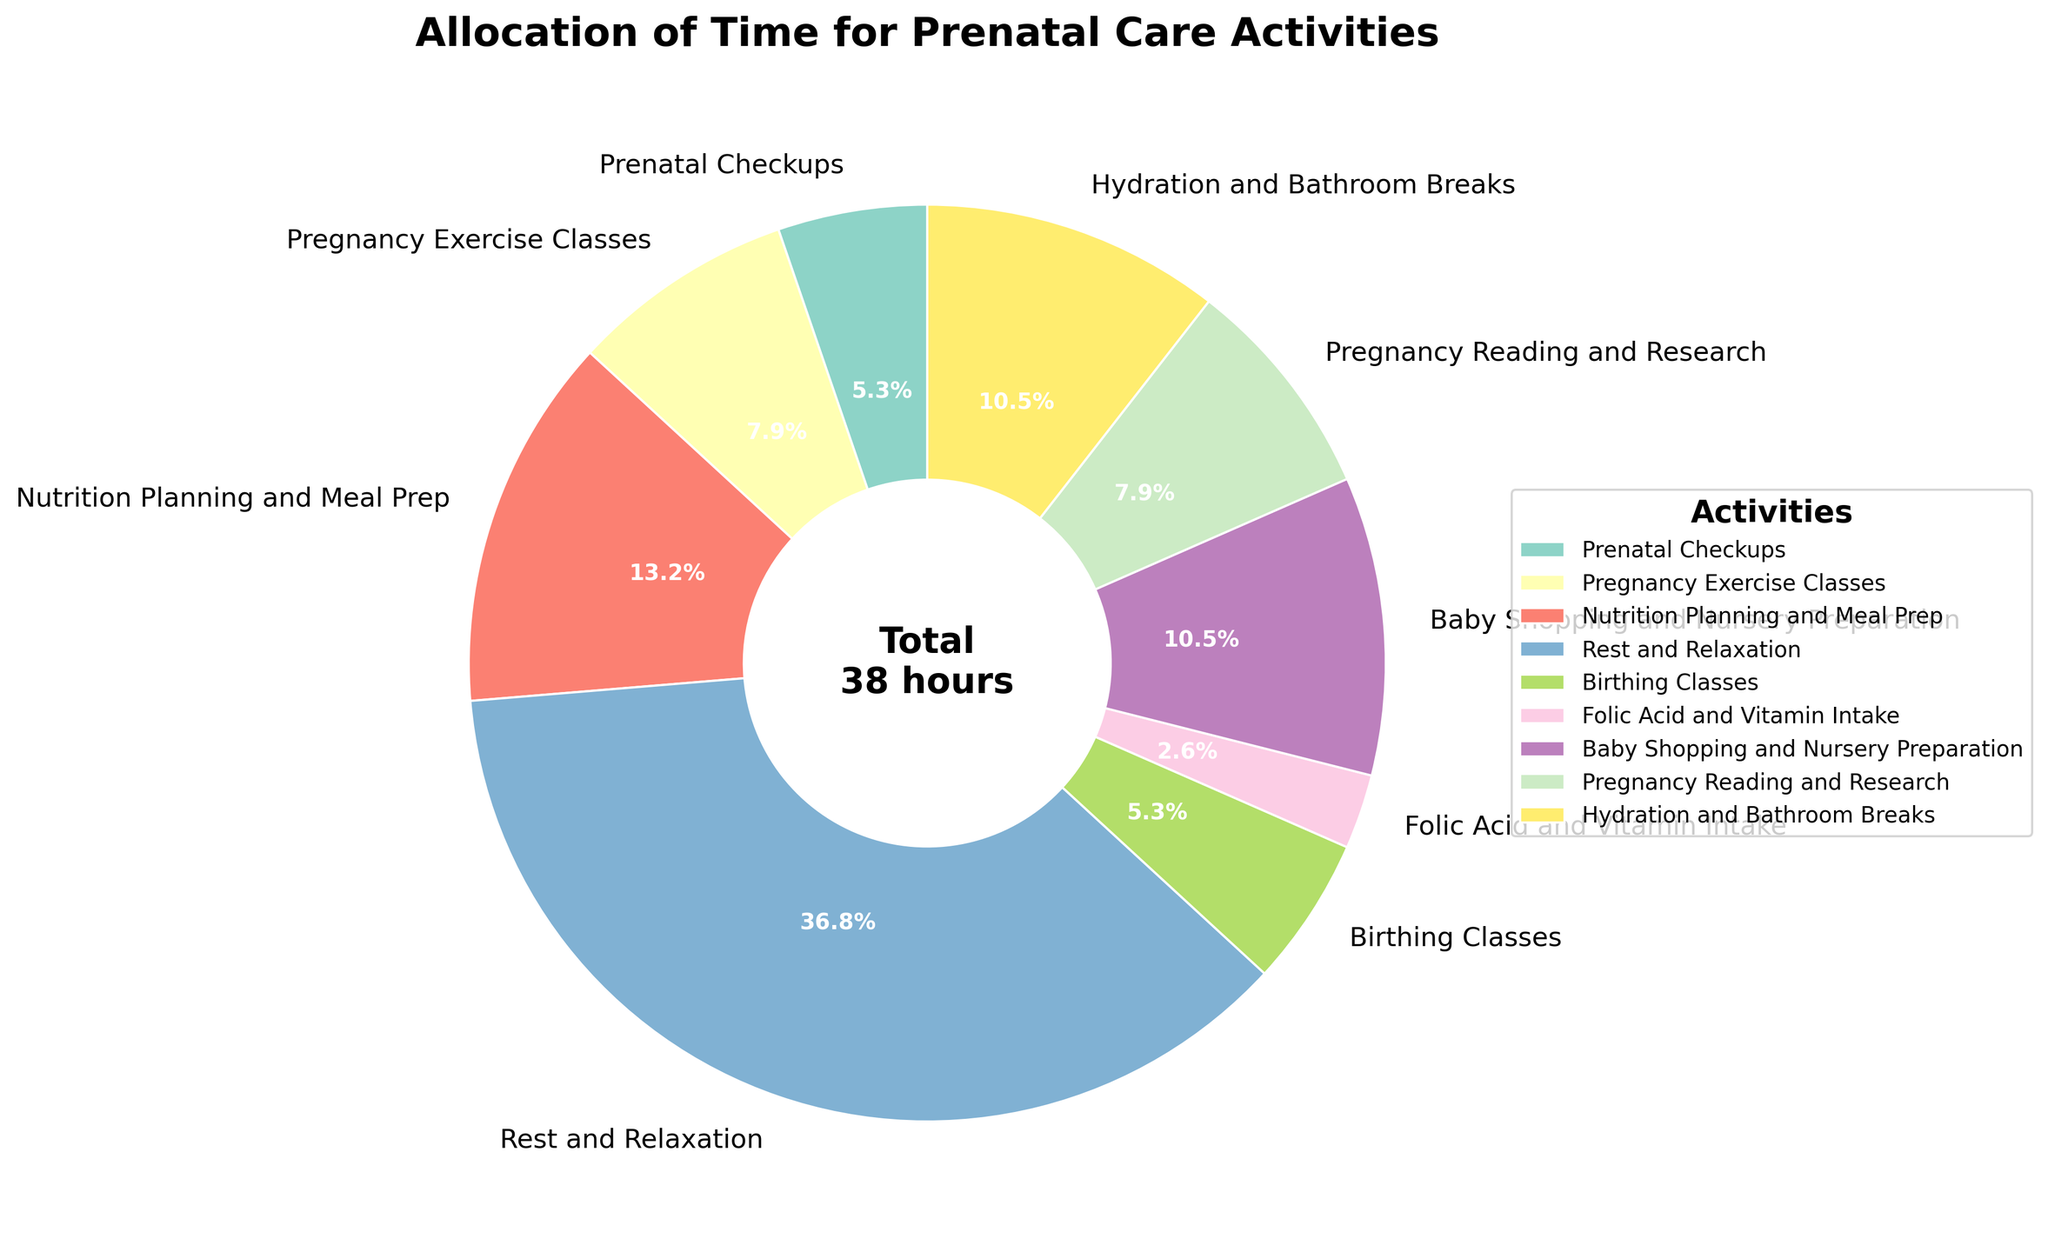What's the largest time allocation for prenatal care activities? The largest slice of the pie chart visually represents the activity with the highest time allocation. The widest wedge corresponds to "Rest and Relaxation", which is allocated 14 hours per week according to the figure.
Answer: Rest and Relaxation How many hours per week are spent on pregnancy exercise classes and nutrition planning combined? Locate the slices for "Pregnancy Exercise Classes" and "Nutrition Planning and Meal Prep". The weekly hours are 3 and 5, respectively. Adding these values gives 3 + 5 = 8 hours.
Answer: 8 Which activity has an equal time allocation to birthing classes? The pie chart shows "Birthing Classes" with 2 hours per week. Scan for another activity with a sector labeled "2 hours", which is "Prenatal Checkups".
Answer: Prenatal Checkups Is more time allocated to baby shopping or pregnancy reading? The pie chart shows "Baby Shopping and Nursery Preparation" with 4 hours and "Pregnancy Reading and Research" with 3 hours. Since 4 is greater than 3, more time is allocated to baby shopping.
Answer: Baby Shopping Which activity has the smallest time allocation? The thinnest slice of the pie chart represents the activity with the least time allocation. "Folic Acid and Vitamin Intake" is the smallest segment, denoted as 1 hour per week.
Answer: Folic Acid and Vitamin Intake How much more time is spent on rest and relaxation compared to prenatal checkups and birthing classes combined? "Rest and Relaxation" is allocated 14 hours, while both "Prenatal Checkups" and "Birthing Classes" are each allocated 2 hours. Sum the hours for checkups and classes: 2 + 2 = 4. The difference is then 14 - 4 = 10 hours.
Answer: 10 What's the total weekly time spent on prenatal care activities? The total weekly time is shown in the center of the chart. Sum all activities: 2 (Checkups) + 3 (Exercise) + 5 (Nutrition) + 14 (Relaxation) + 2 (Birthing) + 1 (Vitamins) + 4 (Shopping) + 3 (Reading) + 4 (Hydration) = 38 hours.
Answer: 38 Which activity has a 10% time allocation? To find 10% of the total weekly hours (38), calculate 38 * 0.10 = 3.8 hours. The closest activity to this is "Pregnancy Reading and Research" at 3 hours but, by percentage approximation, none is precisely 10%.
Answer: None 